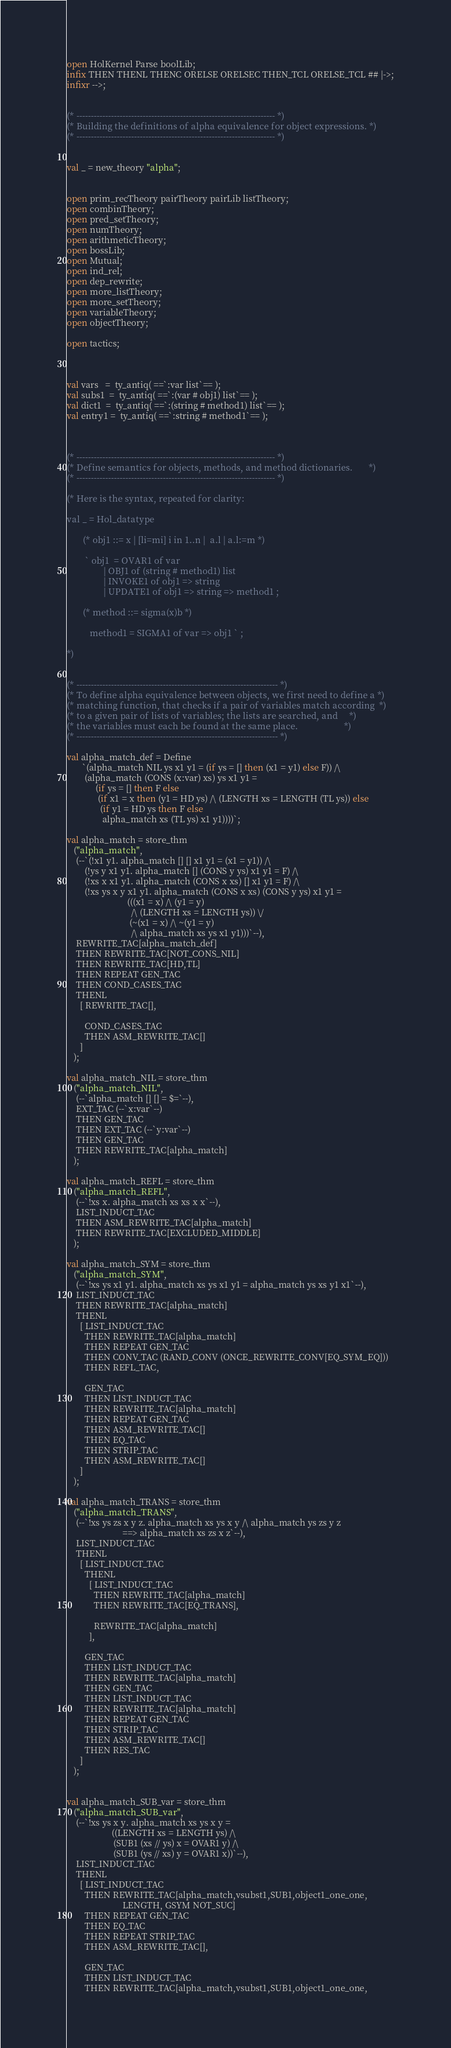Convert code to text. <code><loc_0><loc_0><loc_500><loc_500><_SML_>open HolKernel Parse boolLib;
infix THEN THENL THENC ORELSE ORELSEC THEN_TCL ORELSE_TCL ## |->;
infixr -->;


(* --------------------------------------------------------------------- *)
(* Building the definitions of alpha equivalence for object expressions. *)
(* --------------------------------------------------------------------- *)


val _ = new_theory "alpha";


open prim_recTheory pairTheory pairLib listTheory;
open combinTheory;
open pred_setTheory;
open numTheory;
open arithmeticTheory;
open bossLib;
open Mutual;
open ind_rel;
open dep_rewrite;
open more_listTheory;
open more_setTheory;
open variableTheory;
open objectTheory;

open tactics;



val vars   =  ty_antiq( ==`:var list`== );
val subs1  =  ty_antiq( ==`:(var # obj1) list`== );
val dict1  =  ty_antiq( ==`:(string # method1) list`== );
val entry1 =  ty_antiq( ==`:string # method1`== );



(* --------------------------------------------------------------------- *)
(* Define semantics for objects, methods, and method dictionaries.       *)
(* --------------------------------------------------------------------- *)

(* Here is the syntax, repeated for clarity:

val _ = Hol_datatype

       (* obj1 ::= x | [li=mi] i in 1..n |  a.l | a.l:=m *)

        ` obj1  = OVAR1 of var
                | OBJ1 of (string # method1) list
                | INVOKE1 of obj1 => string
                | UPDATE1 of obj1 => string => method1 ;

       (* method ::= sigma(x)b *)

          method1 = SIGMA1 of var => obj1 ` ;

*)


(* ---------------------------------------------------------------------- *)
(* To define alpha equivalence between objects, we first need to define a *)
(* matching function, that checks if a pair of variables match according  *)
(* to a given pair of lists of variables; the lists are searched, and     *)
(* the variables must each be found at the same place.                    *)
(* ---------------------------------------------------------------------- *)

val alpha_match_def = Define
       `(alpha_match NIL ys x1 y1 = (if ys = [] then (x1 = y1) else F)) /\
        (alpha_match (CONS (x:var) xs) ys x1 y1 =
             (if ys = [] then F else
              (if x1 = x then (y1 = HD ys) /\ (LENGTH xs = LENGTH (TL ys)) else
               (if y1 = HD ys then F else
                alpha_match xs (TL ys) x1 y1))))`;

val alpha_match = store_thm
   ("alpha_match",
    (--`(!x1 y1. alpha_match [] [] x1 y1 = (x1 = y1)) /\
        (!ys y x1 y1. alpha_match [] (CONS y ys) x1 y1 = F) /\
        (!xs x x1 y1. alpha_match (CONS x xs) [] x1 y1 = F) /\
        (!xs ys x y x1 y1. alpha_match (CONS x xs) (CONS y ys) x1 y1 =
                           (((x1 = x) /\ (y1 = y)
                             /\ (LENGTH xs = LENGTH ys)) \/
                            (~(x1 = x) /\ ~(y1 = y)
                             /\ alpha_match xs ys x1 y1)))`--),
    REWRITE_TAC[alpha_match_def]
    THEN REWRITE_TAC[NOT_CONS_NIL]
    THEN REWRITE_TAC[HD,TL]
    THEN REPEAT GEN_TAC
    THEN COND_CASES_TAC
    THENL
      [ REWRITE_TAC[],

        COND_CASES_TAC
        THEN ASM_REWRITE_TAC[]
      ]
   );

val alpha_match_NIL = store_thm
   ("alpha_match_NIL",
    (--`alpha_match [] [] = $=`--),
    EXT_TAC (--`x:var`--)
    THEN GEN_TAC
    THEN EXT_TAC (--`y:var`--)
    THEN GEN_TAC
    THEN REWRITE_TAC[alpha_match]
   );

val alpha_match_REFL = store_thm
   ("alpha_match_REFL",
    (--`!xs x. alpha_match xs xs x x`--),
    LIST_INDUCT_TAC
    THEN ASM_REWRITE_TAC[alpha_match]
    THEN REWRITE_TAC[EXCLUDED_MIDDLE]
   );

val alpha_match_SYM = store_thm
   ("alpha_match_SYM",
    (--`!xs ys x1 y1. alpha_match xs ys x1 y1 = alpha_match ys xs y1 x1`--),
    LIST_INDUCT_TAC
    THEN REWRITE_TAC[alpha_match]
    THENL
      [ LIST_INDUCT_TAC
        THEN REWRITE_TAC[alpha_match]
        THEN REPEAT GEN_TAC
        THEN CONV_TAC (RAND_CONV (ONCE_REWRITE_CONV[EQ_SYM_EQ]))
        THEN REFL_TAC,

        GEN_TAC
        THEN LIST_INDUCT_TAC
        THEN REWRITE_TAC[alpha_match]
        THEN REPEAT GEN_TAC
        THEN ASM_REWRITE_TAC[]
        THEN EQ_TAC
        THEN STRIP_TAC
        THEN ASM_REWRITE_TAC[]
      ]
   );

val alpha_match_TRANS = store_thm
   ("alpha_match_TRANS",
    (--`!xs ys zs x y z. alpha_match xs ys x y /\ alpha_match ys zs y z
                         ==> alpha_match xs zs x z`--),
    LIST_INDUCT_TAC
    THENL
      [ LIST_INDUCT_TAC
        THENL
          [ LIST_INDUCT_TAC
            THEN REWRITE_TAC[alpha_match]
            THEN REWRITE_TAC[EQ_TRANS],

            REWRITE_TAC[alpha_match]
          ],

        GEN_TAC
        THEN LIST_INDUCT_TAC
        THEN REWRITE_TAC[alpha_match]
        THEN GEN_TAC
        THEN LIST_INDUCT_TAC
        THEN REWRITE_TAC[alpha_match]
        THEN REPEAT GEN_TAC
        THEN STRIP_TAC
        THEN ASM_REWRITE_TAC[]
        THEN RES_TAC
      ]
   );


val alpha_match_SUB_var = store_thm
   ("alpha_match_SUB_var",
    (--`!xs ys x y. alpha_match xs ys x y =
                    ((LENGTH xs = LENGTH ys) /\
                     (SUB1 (xs // ys) x = OVAR1 y) /\
                     (SUB1 (ys // xs) y = OVAR1 x))`--),
    LIST_INDUCT_TAC
    THENL
      [ LIST_INDUCT_TAC
        THEN REWRITE_TAC[alpha_match,vsubst1,SUB1,object1_one_one,
                         LENGTH, GSYM NOT_SUC]
        THEN REPEAT GEN_TAC
        THEN EQ_TAC
        THEN REPEAT STRIP_TAC
        THEN ASM_REWRITE_TAC[],

        GEN_TAC
        THEN LIST_INDUCT_TAC
        THEN REWRITE_TAC[alpha_match,vsubst1,SUB1,object1_one_one,</code> 